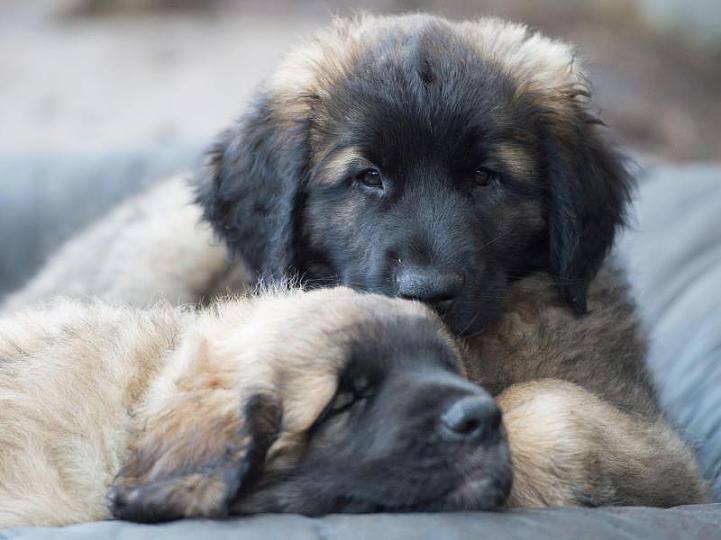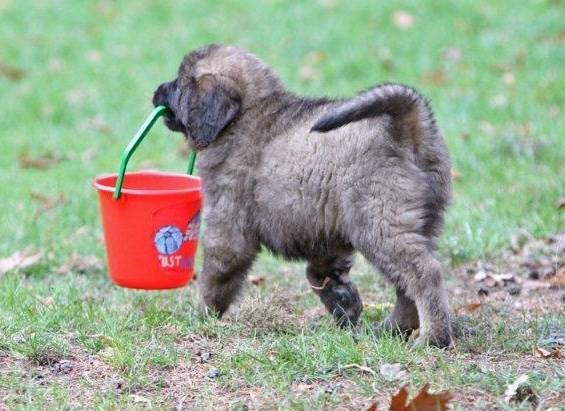The first image is the image on the left, the second image is the image on the right. Examine the images to the left and right. Is the description "A image shows one dog in a snowy outdoor setting." accurate? Answer yes or no. No. The first image is the image on the left, the second image is the image on the right. Evaluate the accuracy of this statement regarding the images: "The dog in one of the images in on grass". Is it true? Answer yes or no. Yes. 